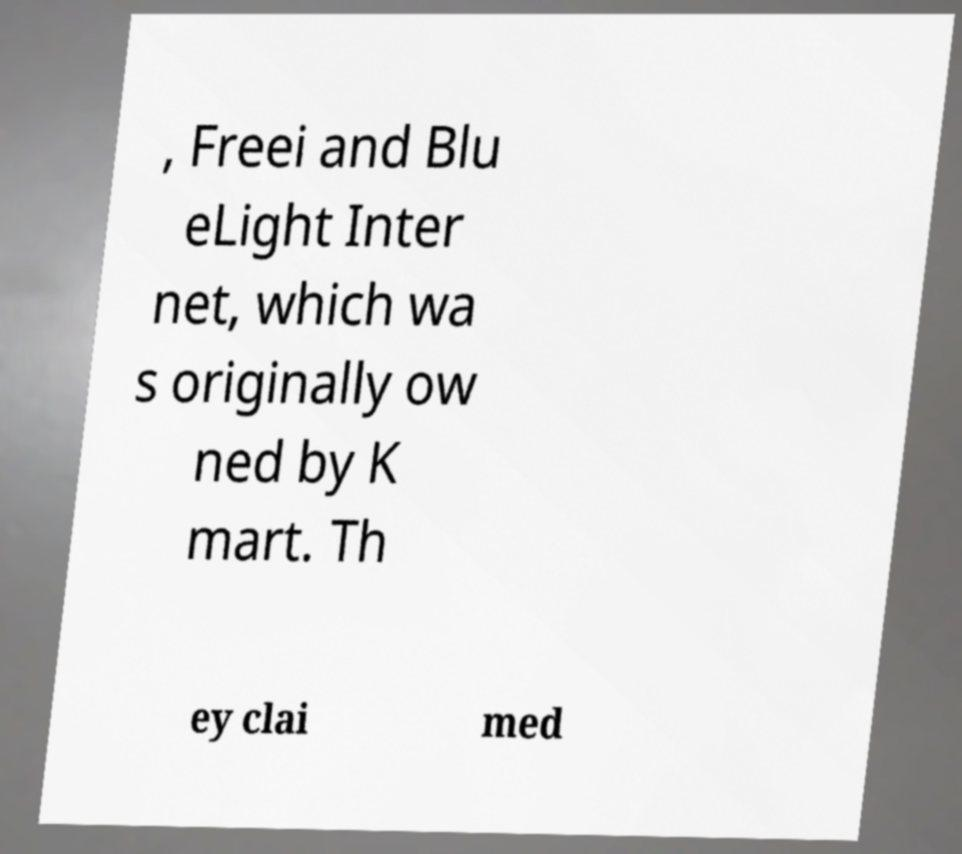Can you accurately transcribe the text from the provided image for me? , Freei and Blu eLight Inter net, which wa s originally ow ned by K mart. Th ey clai med 